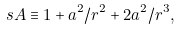Convert formula to latex. <formula><loc_0><loc_0><loc_500><loc_500>\ s A \equiv 1 + a ^ { 2 } / r ^ { 2 } + 2 a ^ { 2 } / r ^ { 3 } ,</formula> 